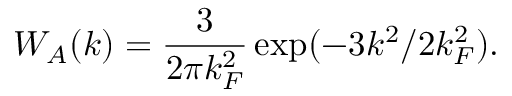<formula> <loc_0><loc_0><loc_500><loc_500>W _ { A } ( k ) = \frac { 3 } { 2 \pi k _ { F } ^ { 2 } } \exp ( - 3 k ^ { 2 } / 2 k _ { F } ^ { 2 } ) .</formula> 